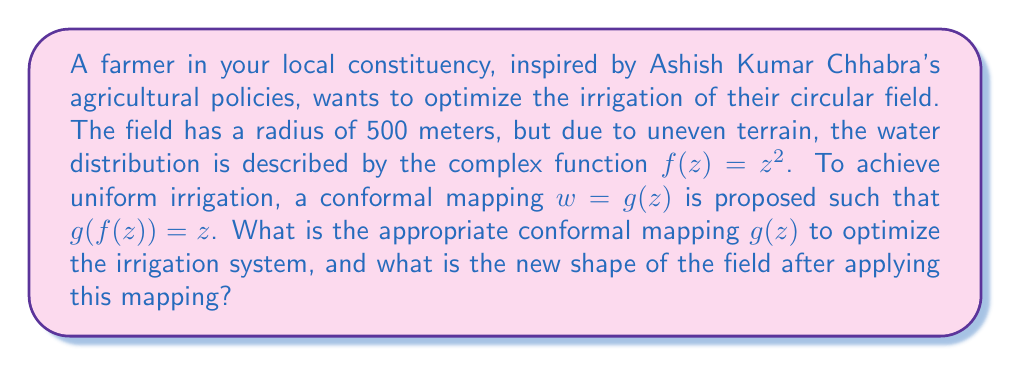Give your solution to this math problem. To solve this problem, we need to follow these steps:

1) We are given that $f(z) = z^2$. We need to find $g(z)$ such that $g(f(z)) = z$.

2) Substituting $f(z)$ into $g(z)$, we get:

   $g(z^2) = z$

3) To find $g(z)$, we replace $z^2$ with $z$:

   $g(z) = \sqrt{z}$

4) Therefore, the appropriate conformal mapping is $g(z) = \sqrt{z}$.

5) To determine the new shape of the field, we need to apply this mapping to the boundary of the original circular field.

6) The equation of the original circular field is:

   $|z| = 500$

7) Applying the mapping $w = \sqrt{z}$:

   $|w|^2 = |\sqrt{z}|^2 = |z| = 500$

8) This gives us:

   $|w| = \sqrt{500} \approx 22.36$

9) In polar form, we can write $z = 500e^{i\theta}$ where $0 \leq \theta < 2\pi$.

10) Applying the mapping:

    $w = \sqrt{500e^{i\theta}} = \sqrt{500} \cdot e^{i\theta/2} \approx 22.36 \cdot e^{i\theta/2}$

11) As $\theta$ goes from 0 to $2\pi$, $\theta/2$ goes from 0 to $\pi$.

Therefore, the new shape of the field is a half-circle with radius approximately 22.36 meters.
Answer: The appropriate conformal mapping is $g(z) = \sqrt{z}$. After applying this mapping, the circular field transforms into a half-circle with radius $\sqrt{500} \approx 22.36$ meters. 